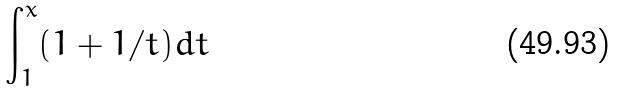<formula> <loc_0><loc_0><loc_500><loc_500>\int _ { 1 } ^ { x } ( 1 + 1 / t ) d t</formula> 